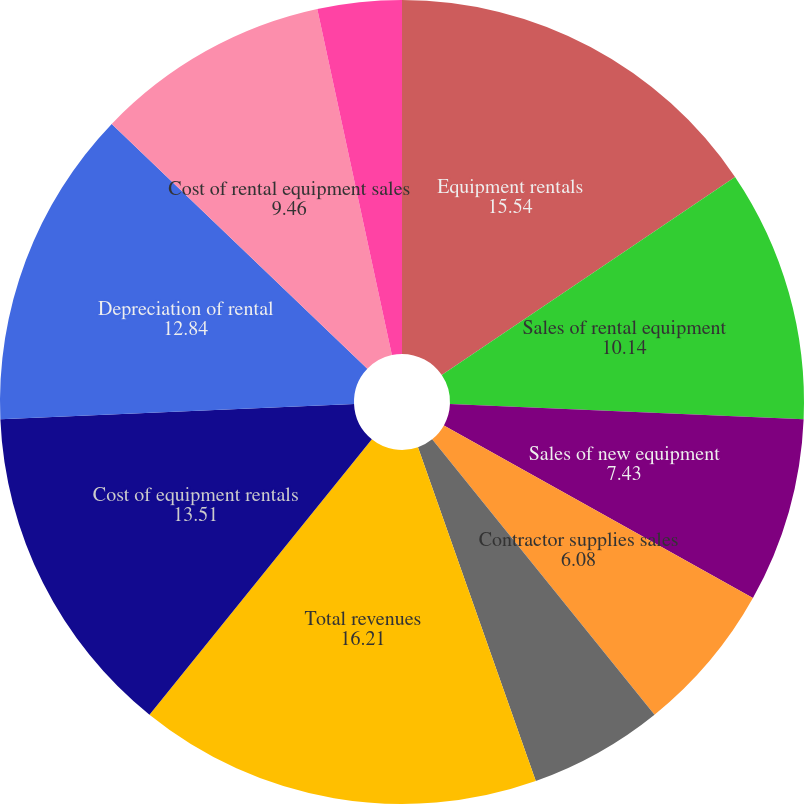Convert chart to OTSL. <chart><loc_0><loc_0><loc_500><loc_500><pie_chart><fcel>Equipment rentals<fcel>Sales of rental equipment<fcel>Sales of new equipment<fcel>Contractor supplies sales<fcel>Service and other revenues<fcel>Total revenues<fcel>Cost of equipment rentals<fcel>Depreciation of rental<fcel>Cost of rental equipment sales<fcel>Cost of new equipment sales<nl><fcel>15.54%<fcel>10.14%<fcel>7.43%<fcel>6.08%<fcel>5.41%<fcel>16.21%<fcel>13.51%<fcel>12.84%<fcel>9.46%<fcel>3.38%<nl></chart> 